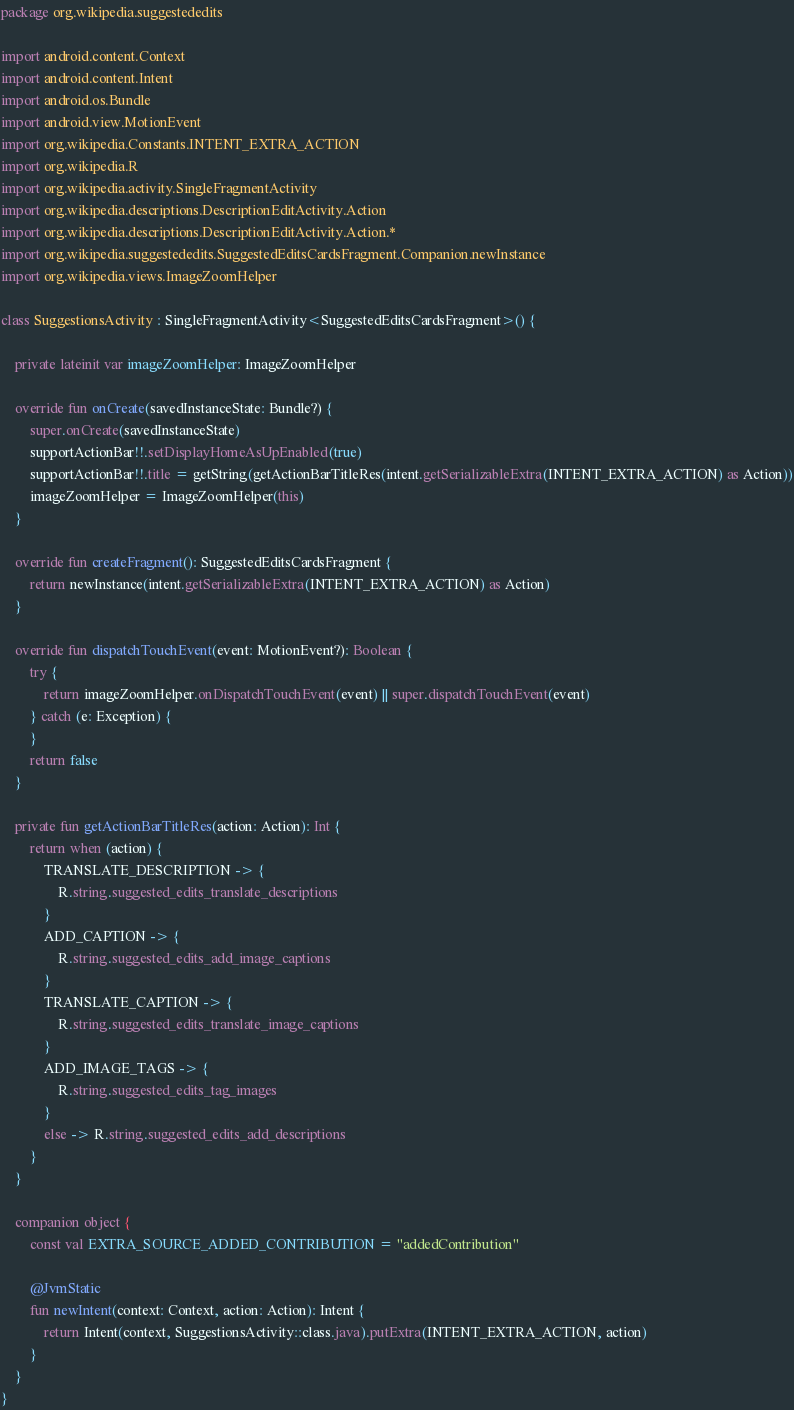<code> <loc_0><loc_0><loc_500><loc_500><_Kotlin_>package org.wikipedia.suggestededits

import android.content.Context
import android.content.Intent
import android.os.Bundle
import android.view.MotionEvent
import org.wikipedia.Constants.INTENT_EXTRA_ACTION
import org.wikipedia.R
import org.wikipedia.activity.SingleFragmentActivity
import org.wikipedia.descriptions.DescriptionEditActivity.Action
import org.wikipedia.descriptions.DescriptionEditActivity.Action.*
import org.wikipedia.suggestededits.SuggestedEditsCardsFragment.Companion.newInstance
import org.wikipedia.views.ImageZoomHelper

class SuggestionsActivity : SingleFragmentActivity<SuggestedEditsCardsFragment>() {

    private lateinit var imageZoomHelper: ImageZoomHelper

    override fun onCreate(savedInstanceState: Bundle?) {
        super.onCreate(savedInstanceState)
        supportActionBar!!.setDisplayHomeAsUpEnabled(true)
        supportActionBar!!.title = getString(getActionBarTitleRes(intent.getSerializableExtra(INTENT_EXTRA_ACTION) as Action))
        imageZoomHelper = ImageZoomHelper(this)
    }

    override fun createFragment(): SuggestedEditsCardsFragment {
        return newInstance(intent.getSerializableExtra(INTENT_EXTRA_ACTION) as Action)
    }

    override fun dispatchTouchEvent(event: MotionEvent?): Boolean {
        try {
            return imageZoomHelper.onDispatchTouchEvent(event) || super.dispatchTouchEvent(event)
        } catch (e: Exception) {
        }
        return false
    }

    private fun getActionBarTitleRes(action: Action): Int {
        return when (action) {
            TRANSLATE_DESCRIPTION -> {
                R.string.suggested_edits_translate_descriptions
            }
            ADD_CAPTION -> {
                R.string.suggested_edits_add_image_captions
            }
            TRANSLATE_CAPTION -> {
                R.string.suggested_edits_translate_image_captions
            }
            ADD_IMAGE_TAGS -> {
                R.string.suggested_edits_tag_images
            }
            else -> R.string.suggested_edits_add_descriptions
        }
    }

    companion object {
        const val EXTRA_SOURCE_ADDED_CONTRIBUTION = "addedContribution"

        @JvmStatic
        fun newIntent(context: Context, action: Action): Intent {
            return Intent(context, SuggestionsActivity::class.java).putExtra(INTENT_EXTRA_ACTION, action)
        }
    }
}
</code> 